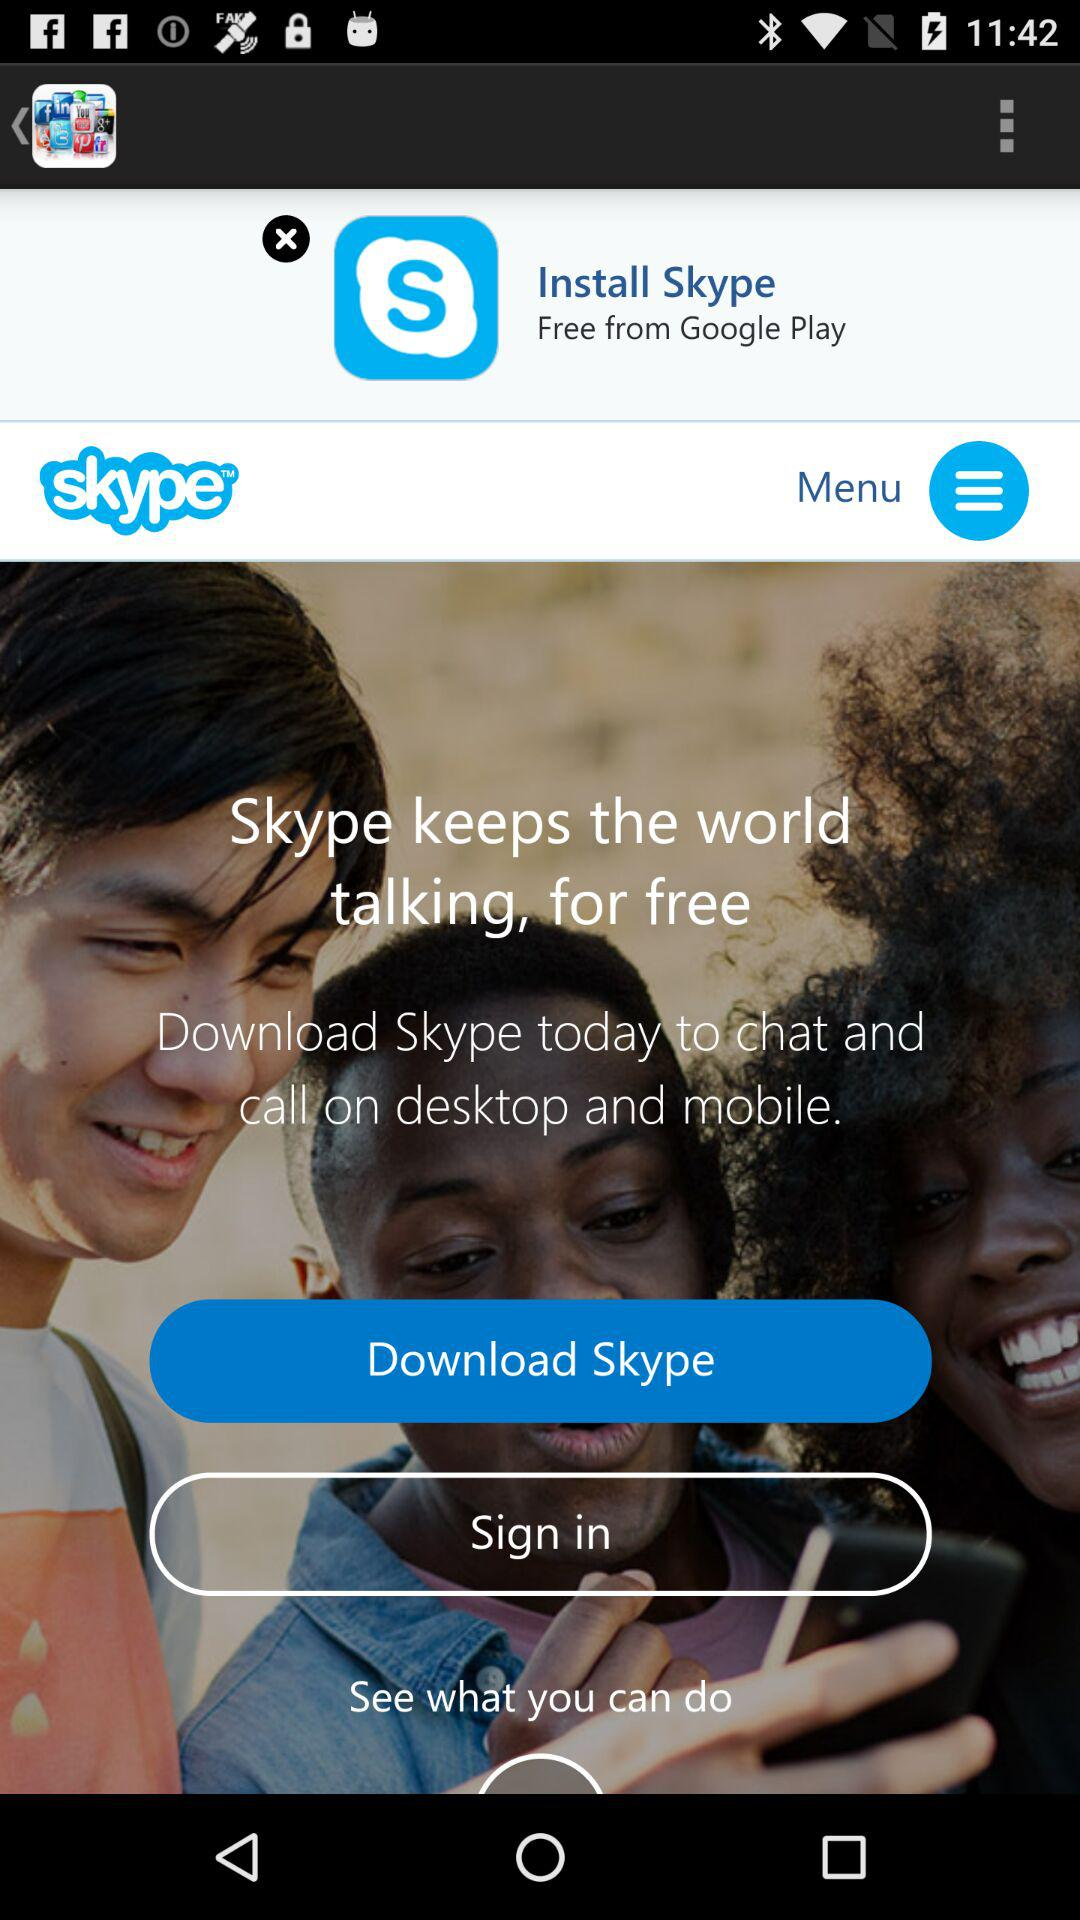What is the name of the application? The name of the application is "Skype". 